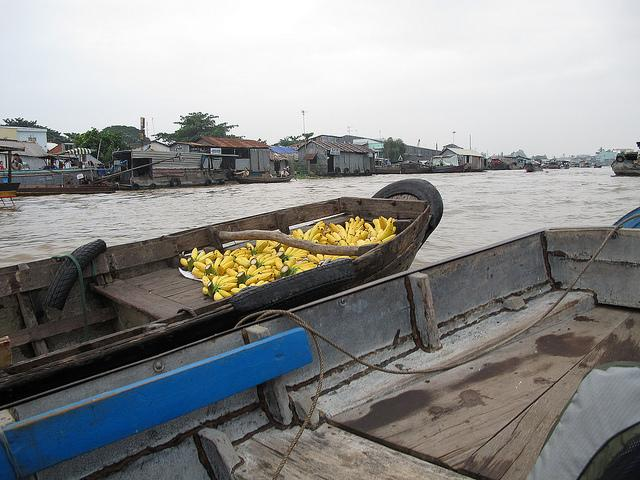What food is on the boat? bananas 